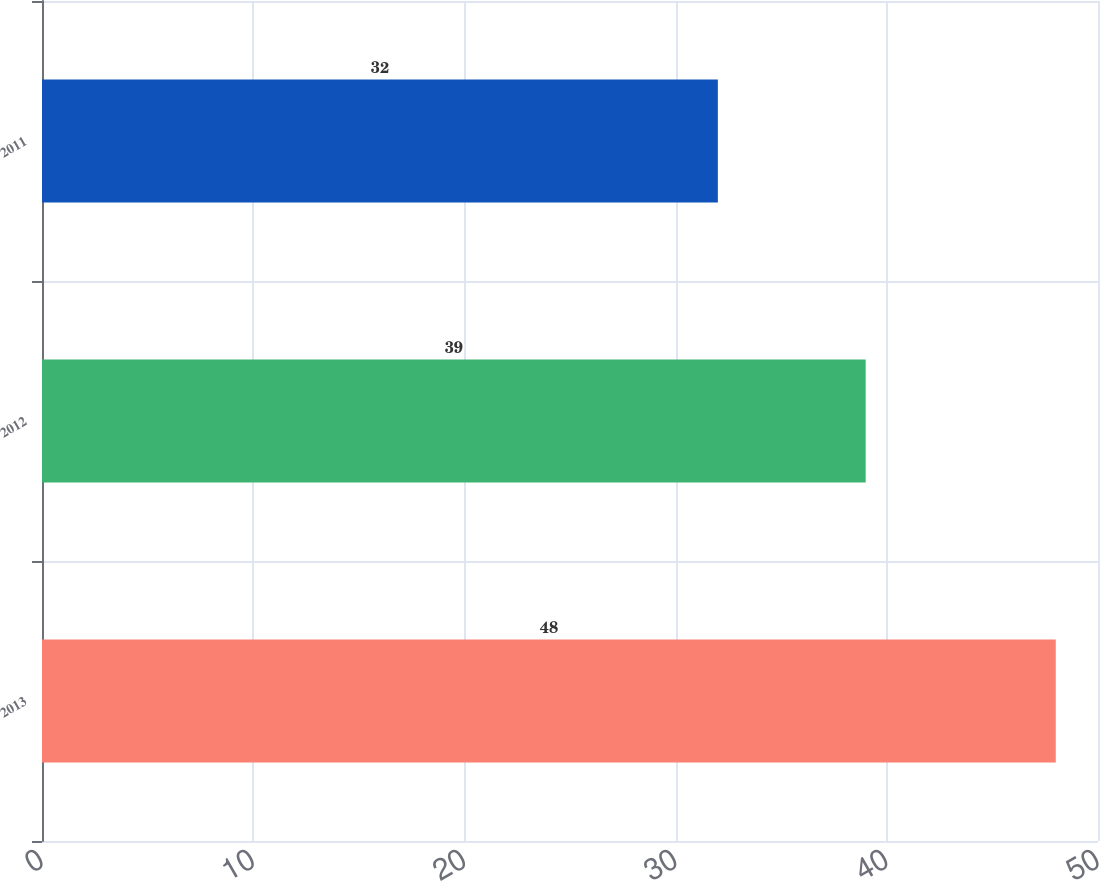<chart> <loc_0><loc_0><loc_500><loc_500><bar_chart><fcel>2013<fcel>2012<fcel>2011<nl><fcel>48<fcel>39<fcel>32<nl></chart> 